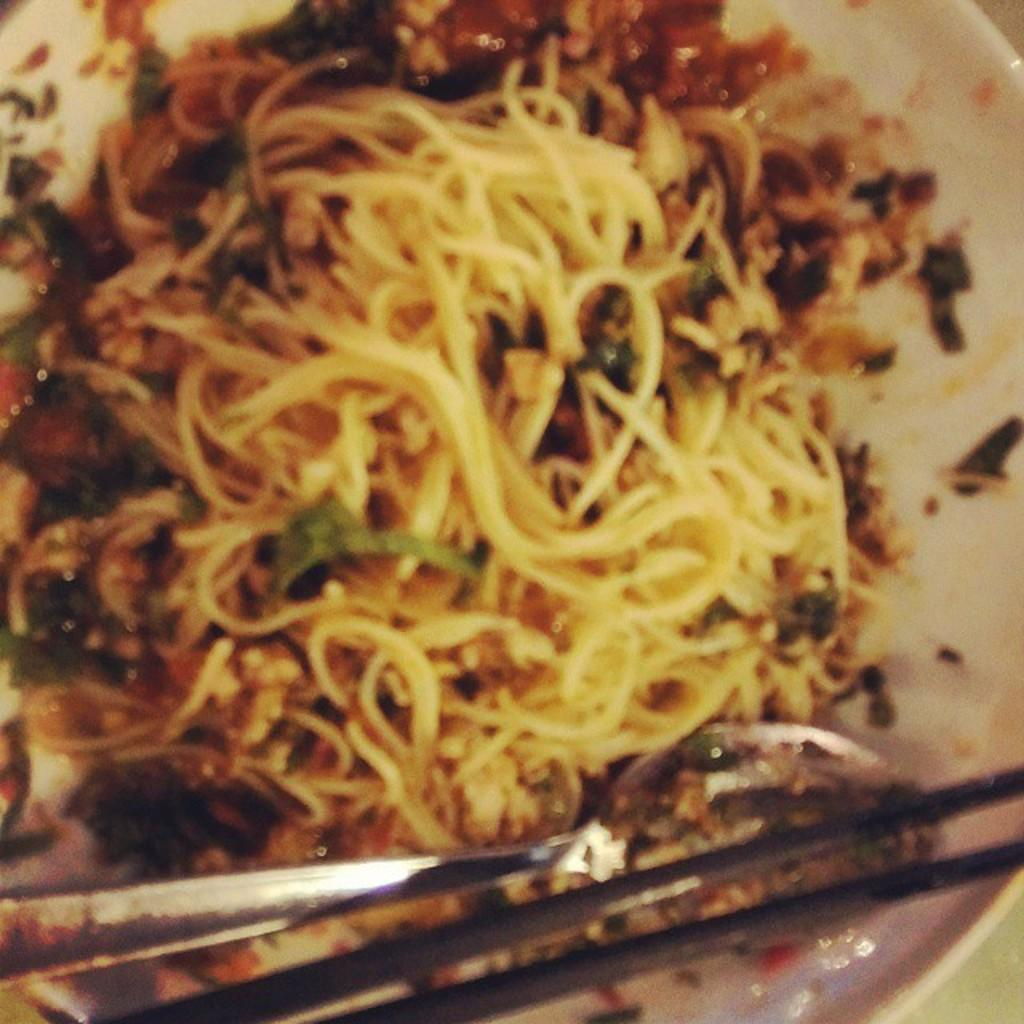What is on the plate in the image? There is a food item on the plate. What utensil is placed with the food item on the plate? There is a spoon on the plate. What other utensil is placed with the food item on the plate? There are chopsticks on the plate. What type of horn can be seen on the plate in the image? There is no horn present on the plate in the image. 